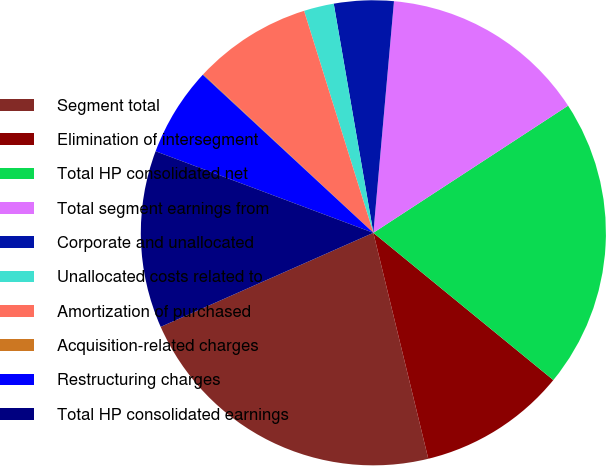Convert chart. <chart><loc_0><loc_0><loc_500><loc_500><pie_chart><fcel>Segment total<fcel>Elimination of intersegment<fcel>Total HP consolidated net<fcel>Total segment earnings from<fcel>Corporate and unallocated<fcel>Unallocated costs related to<fcel>Amortization of purchased<fcel>Acquisition-related charges<fcel>Restructuring charges<fcel>Total HP consolidated earnings<nl><fcel>22.17%<fcel>10.29%<fcel>20.12%<fcel>14.38%<fcel>4.14%<fcel>2.09%<fcel>8.24%<fcel>0.05%<fcel>6.19%<fcel>12.33%<nl></chart> 